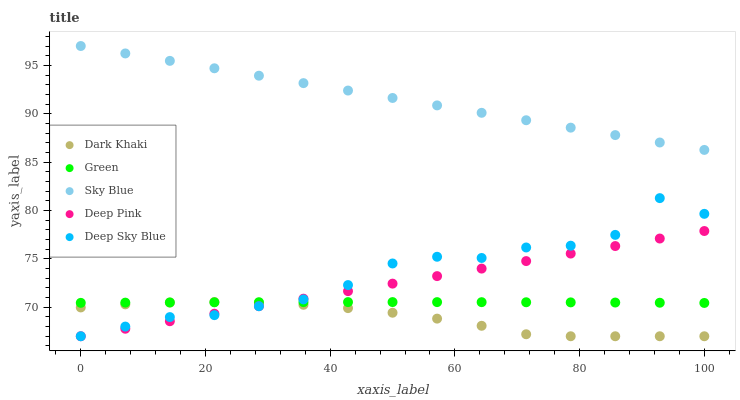Does Dark Khaki have the minimum area under the curve?
Answer yes or no. Yes. Does Sky Blue have the maximum area under the curve?
Answer yes or no. Yes. Does Deep Pink have the minimum area under the curve?
Answer yes or no. No. Does Deep Pink have the maximum area under the curve?
Answer yes or no. No. Is Deep Pink the smoothest?
Answer yes or no. Yes. Is Deep Sky Blue the roughest?
Answer yes or no. Yes. Is Sky Blue the smoothest?
Answer yes or no. No. Is Sky Blue the roughest?
Answer yes or no. No. Does Dark Khaki have the lowest value?
Answer yes or no. Yes. Does Sky Blue have the lowest value?
Answer yes or no. No. Does Sky Blue have the highest value?
Answer yes or no. Yes. Does Deep Pink have the highest value?
Answer yes or no. No. Is Deep Pink less than Sky Blue?
Answer yes or no. Yes. Is Sky Blue greater than Green?
Answer yes or no. Yes. Does Green intersect Deep Pink?
Answer yes or no. Yes. Is Green less than Deep Pink?
Answer yes or no. No. Is Green greater than Deep Pink?
Answer yes or no. No. Does Deep Pink intersect Sky Blue?
Answer yes or no. No. 